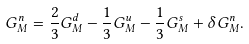<formula> <loc_0><loc_0><loc_500><loc_500>G _ { M } ^ { n } = \frac { 2 } { 3 } G _ { M } ^ { d } - \frac { 1 } { 3 } G _ { M } ^ { u } - \frac { 1 } { 3 } G _ { M } ^ { s } + \delta G _ { M } ^ { n } .</formula> 